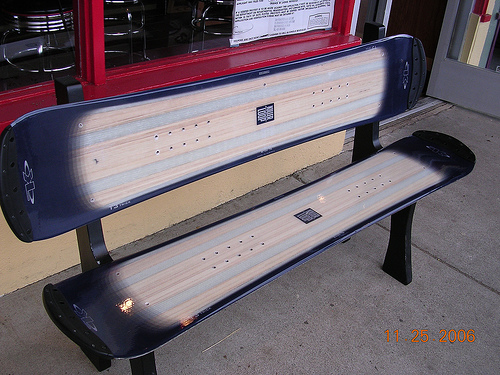<image>
Can you confirm if the snowboard is on the bench? Yes. Looking at the image, I can see the snowboard is positioned on top of the bench, with the bench providing support. 